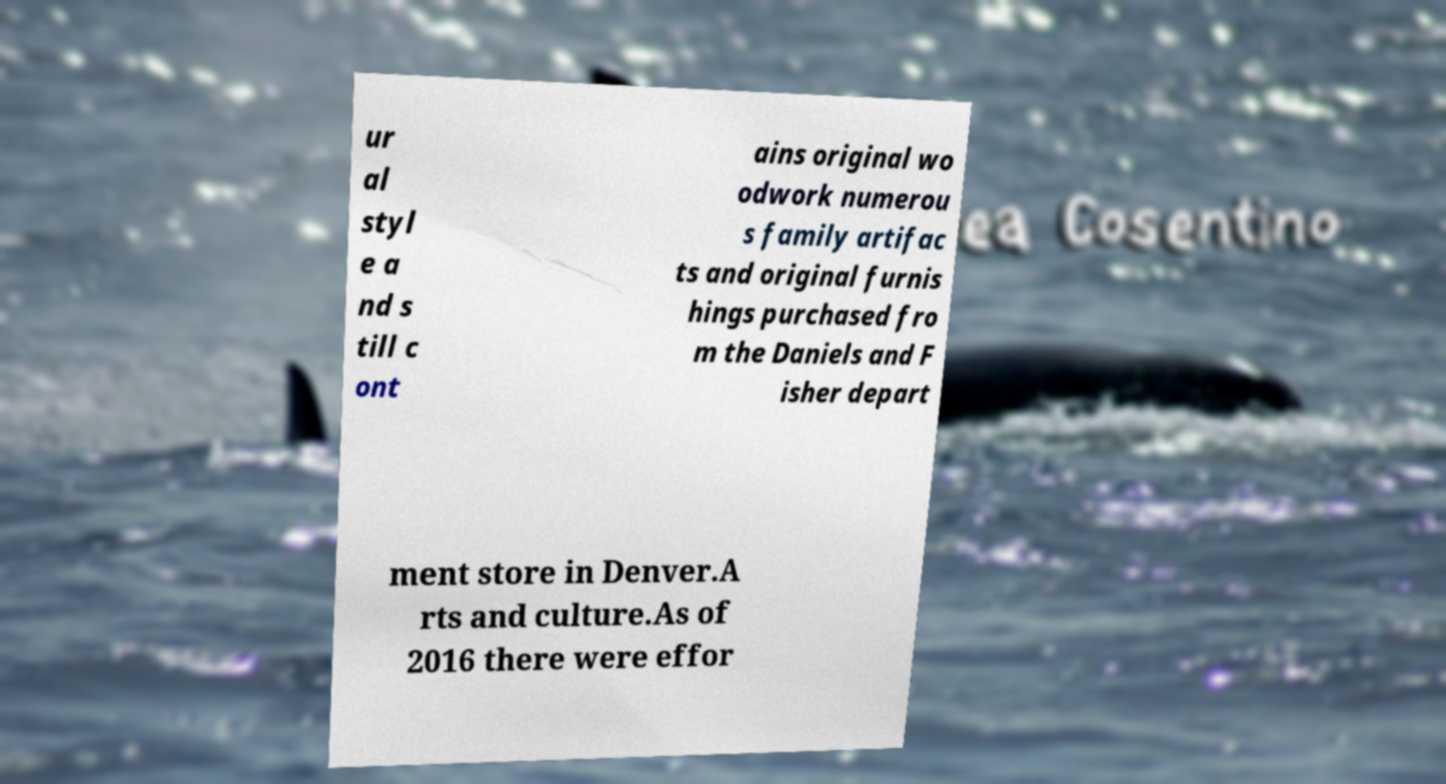Please read and relay the text visible in this image. What does it say? ur al styl e a nd s till c ont ains original wo odwork numerou s family artifac ts and original furnis hings purchased fro m the Daniels and F isher depart ment store in Denver.A rts and culture.As of 2016 there were effor 